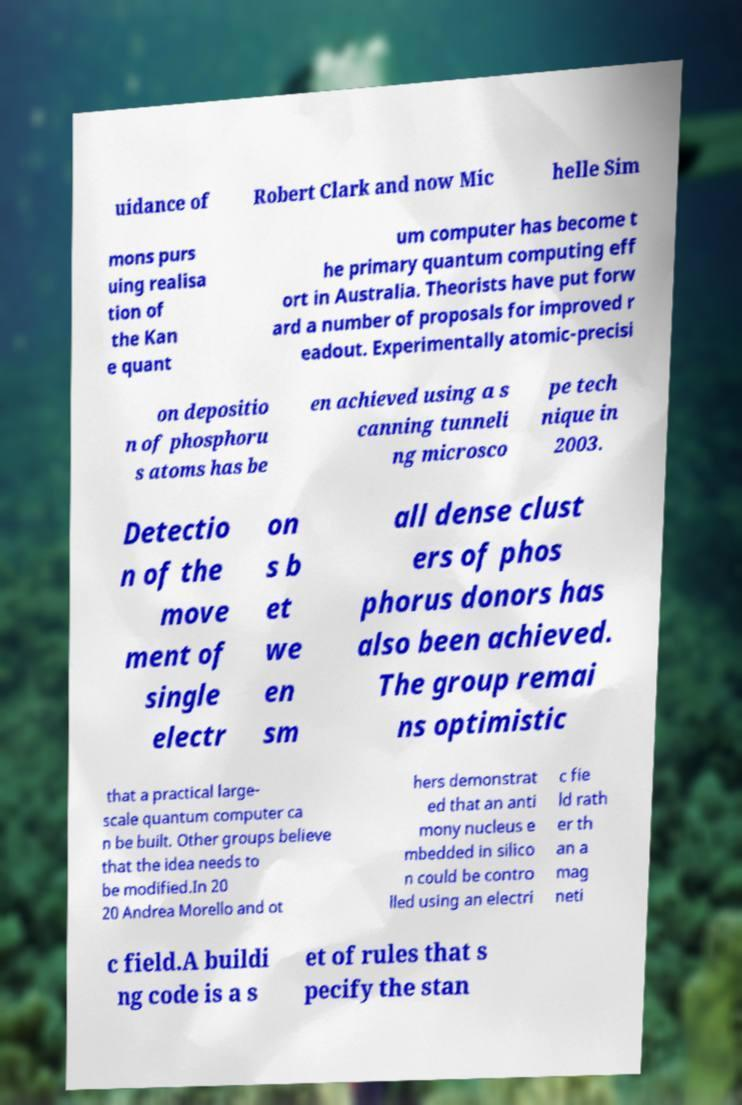For documentation purposes, I need the text within this image transcribed. Could you provide that? uidance of Robert Clark and now Mic helle Sim mons purs uing realisa tion of the Kan e quant um computer has become t he primary quantum computing eff ort in Australia. Theorists have put forw ard a number of proposals for improved r eadout. Experimentally atomic-precisi on depositio n of phosphoru s atoms has be en achieved using a s canning tunneli ng microsco pe tech nique in 2003. Detectio n of the move ment of single electr on s b et we en sm all dense clust ers of phos phorus donors has also been achieved. The group remai ns optimistic that a practical large- scale quantum computer ca n be built. Other groups believe that the idea needs to be modified.In 20 20 Andrea Morello and ot hers demonstrat ed that an anti mony nucleus e mbedded in silico n could be contro lled using an electri c fie ld rath er th an a mag neti c field.A buildi ng code is a s et of rules that s pecify the stan 